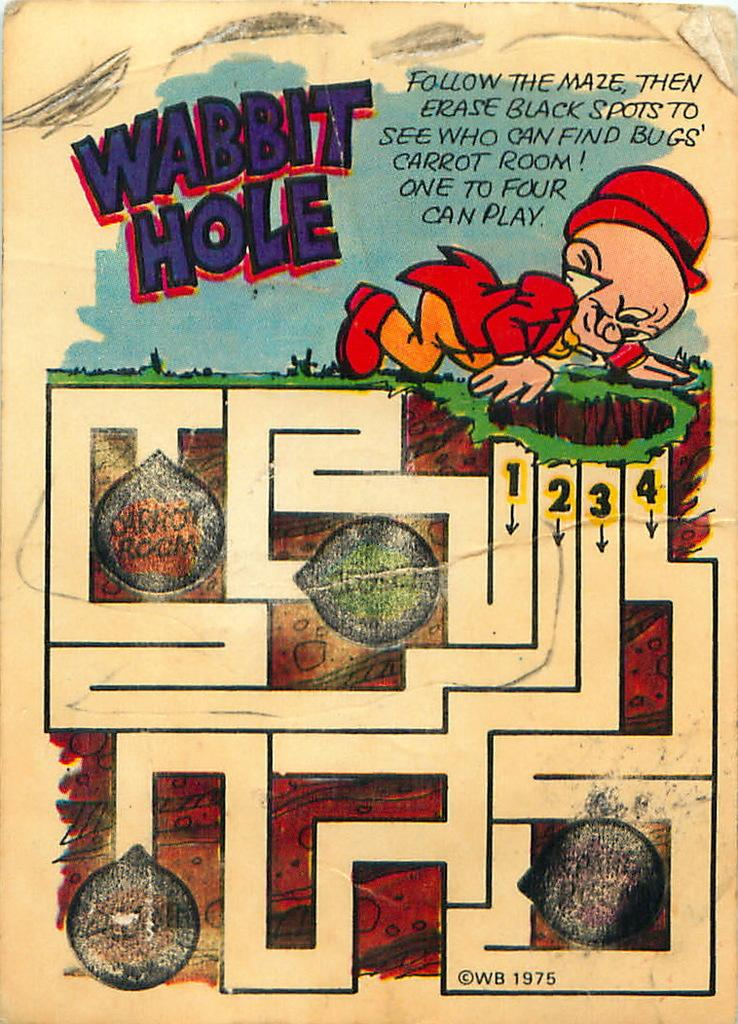<image>
Render a clear and concise summary of the photo. Elmer fudd looking for the carrot room, this is a maze. 